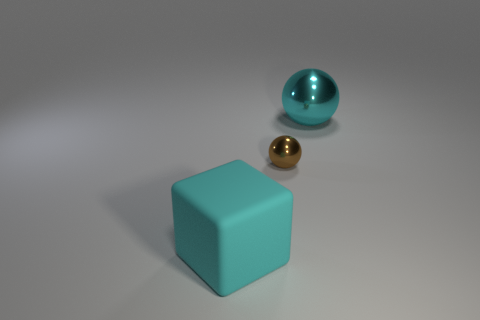Add 1 large metallic things. How many objects exist? 4 Subtract all spheres. How many objects are left? 1 Add 1 red shiny blocks. How many red shiny blocks exist? 1 Subtract 0 green blocks. How many objects are left? 3 Subtract all big yellow spheres. Subtract all large blocks. How many objects are left? 2 Add 1 tiny brown balls. How many tiny brown balls are left? 2 